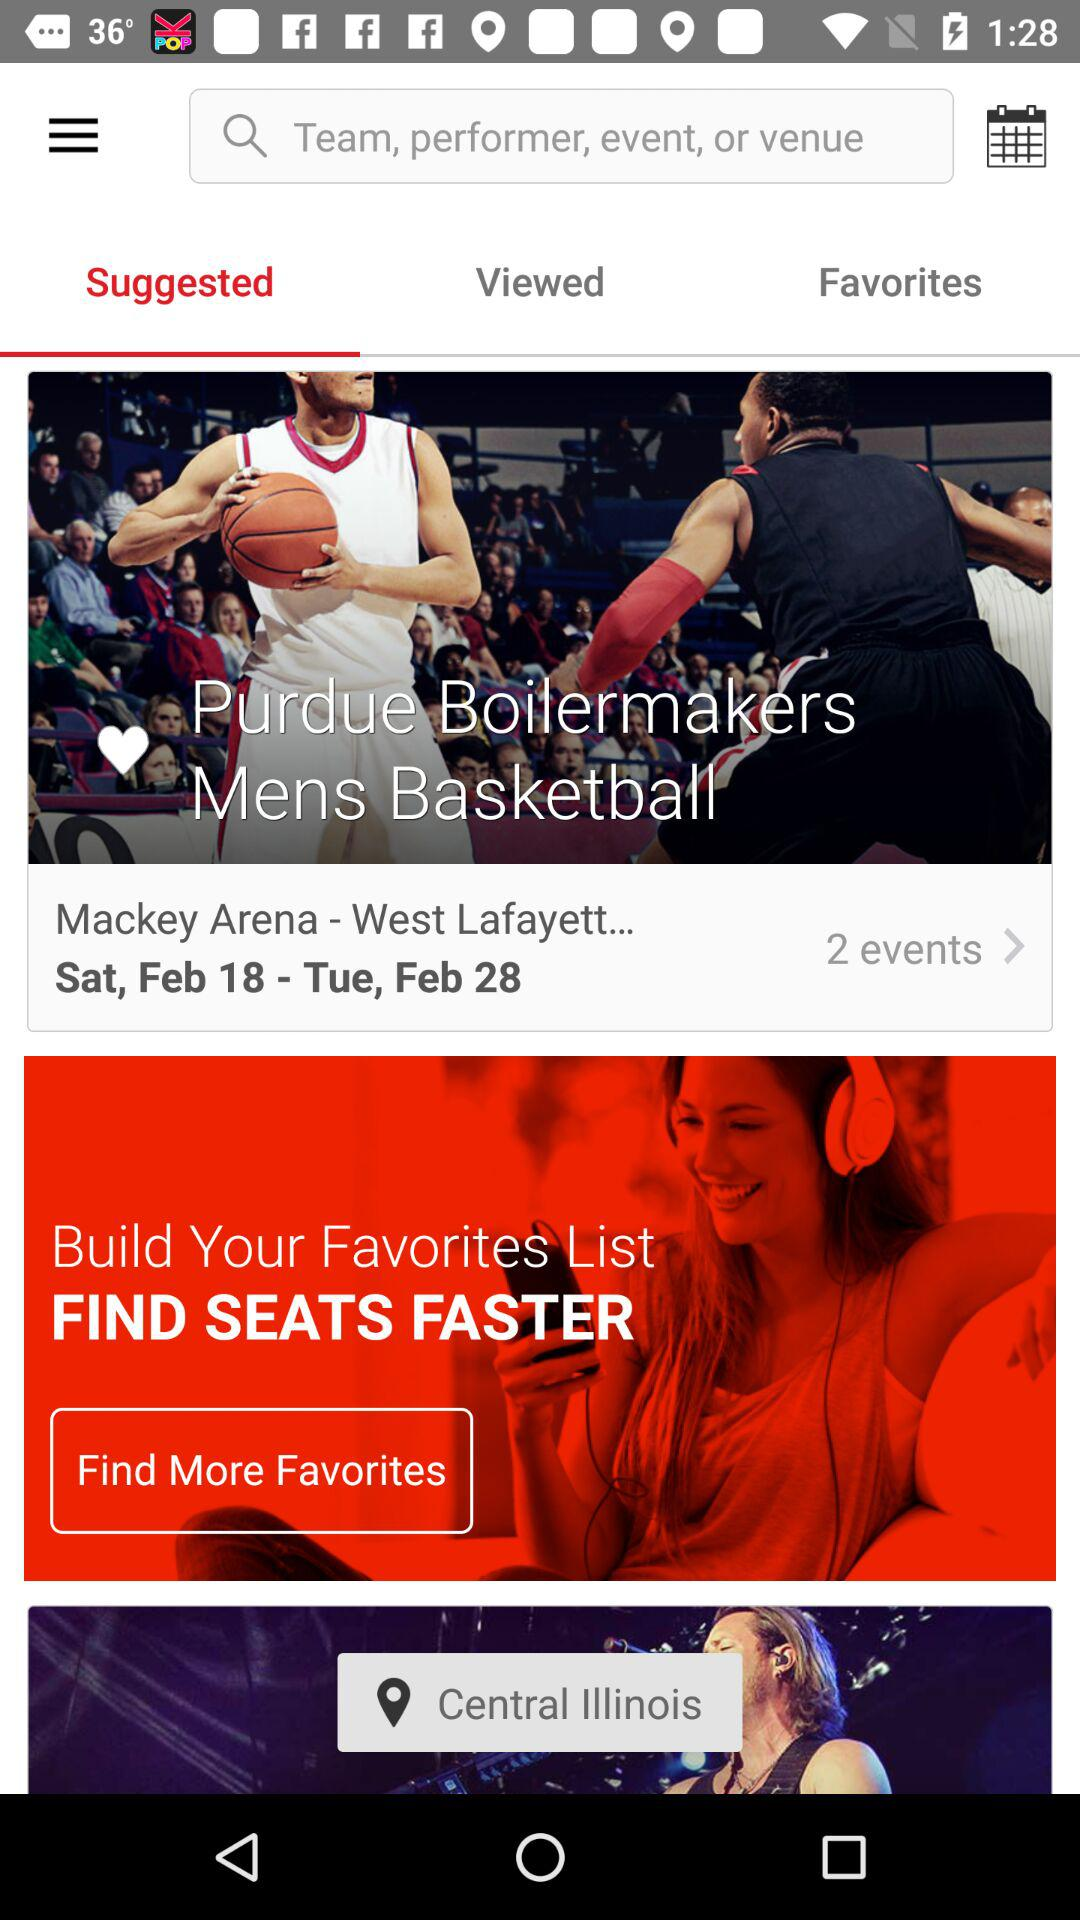What is the location? The location is Central Illinois. 